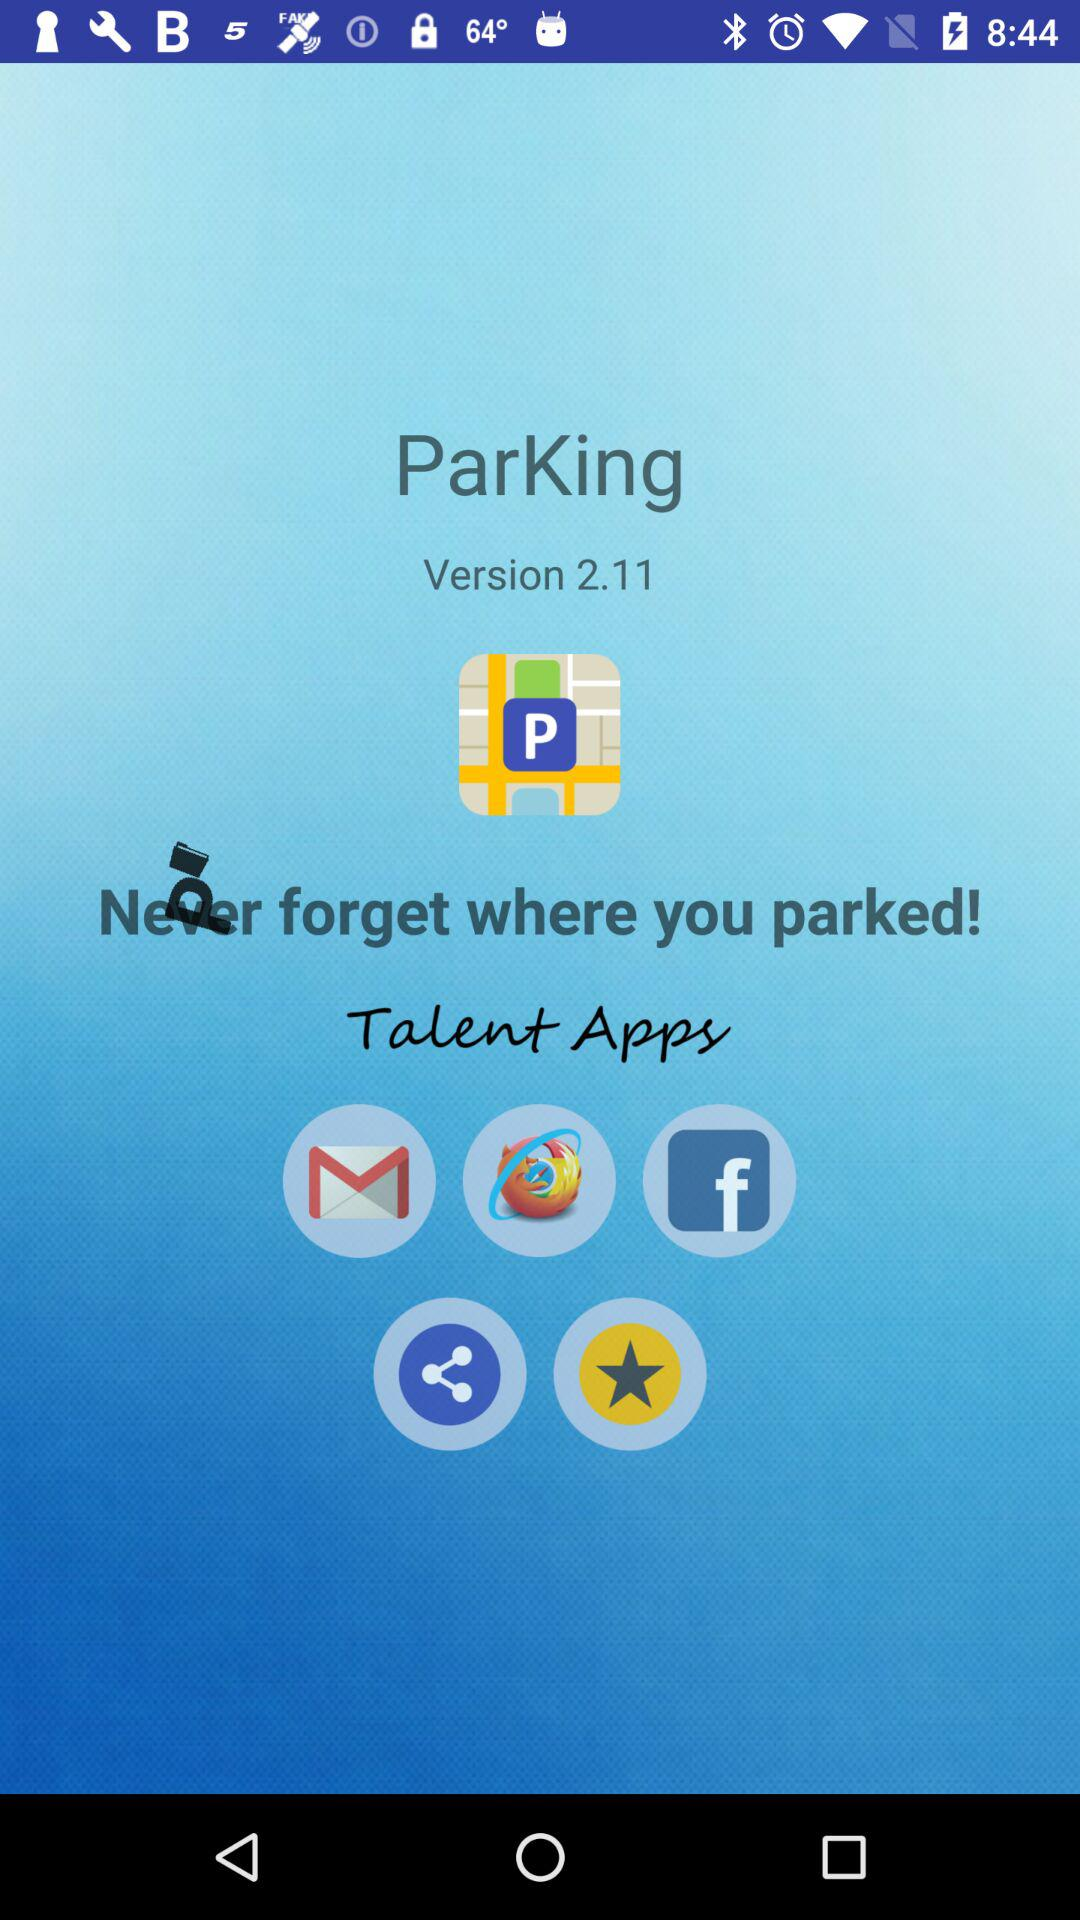What is the app name? The app name is "ParKing". 